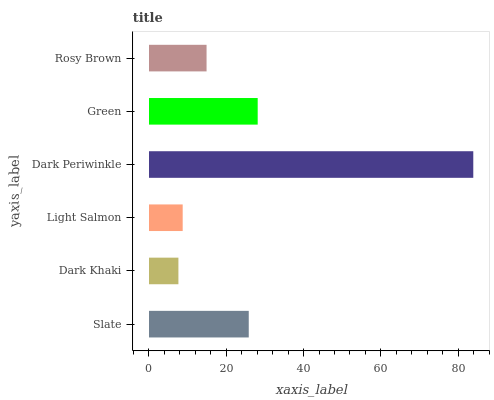Is Dark Khaki the minimum?
Answer yes or no. Yes. Is Dark Periwinkle the maximum?
Answer yes or no. Yes. Is Light Salmon the minimum?
Answer yes or no. No. Is Light Salmon the maximum?
Answer yes or no. No. Is Light Salmon greater than Dark Khaki?
Answer yes or no. Yes. Is Dark Khaki less than Light Salmon?
Answer yes or no. Yes. Is Dark Khaki greater than Light Salmon?
Answer yes or no. No. Is Light Salmon less than Dark Khaki?
Answer yes or no. No. Is Slate the high median?
Answer yes or no. Yes. Is Rosy Brown the low median?
Answer yes or no. Yes. Is Dark Periwinkle the high median?
Answer yes or no. No. Is Dark Periwinkle the low median?
Answer yes or no. No. 